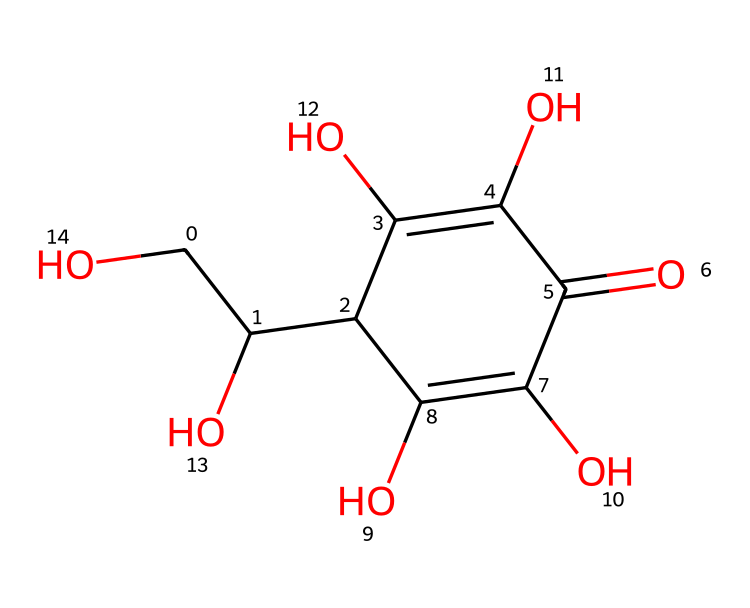how many carbon atoms are in the chemical structure? The chemical structure has a total of 6 carbon atoms, which can be counted by identifying the "C" in the SMILES representation and tallying their occurrences.
Answer: 6 how many hydroxyl groups (-OH) are present? The structure features 4 hydroxyl groups, identified by the presence of "O" followed by "H," appearing four times in the SMILES.
Answer: 4 what type of compound is this? This compound is an antioxidant, specifically vitamin C, which is recognized for its role in cellular protection against oxidative stress.
Answer: antioxidant what is the molecular formula represented by the structure? The structure corresponds to the molecular formula C6H8O6, which can be derived by counting the individual atoms of each element from the SMILES code.
Answer: C6H8O6 which functional groups are present in this molecule? The molecule contains hydroxyl (-OH) functional groups and a carbonyl (C=O) group, identifiable from the structure since they feature prominently in the SMILES notation.
Answer: hydroxyl, carbonyl what is the role of vitamin C as an antioxidant? Vitamin C acts as a reducing agent, donating electrons to neutralize free radicals in the body, which protects cells from oxidative damage.
Answer: reducing agent 